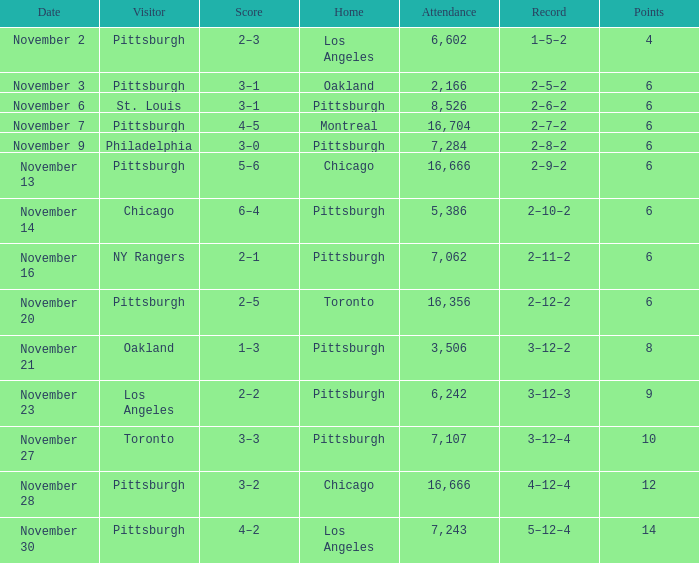What is the sum of the points of the game with philadelphia as the visitor and an attendance greater than 7,284? None. 